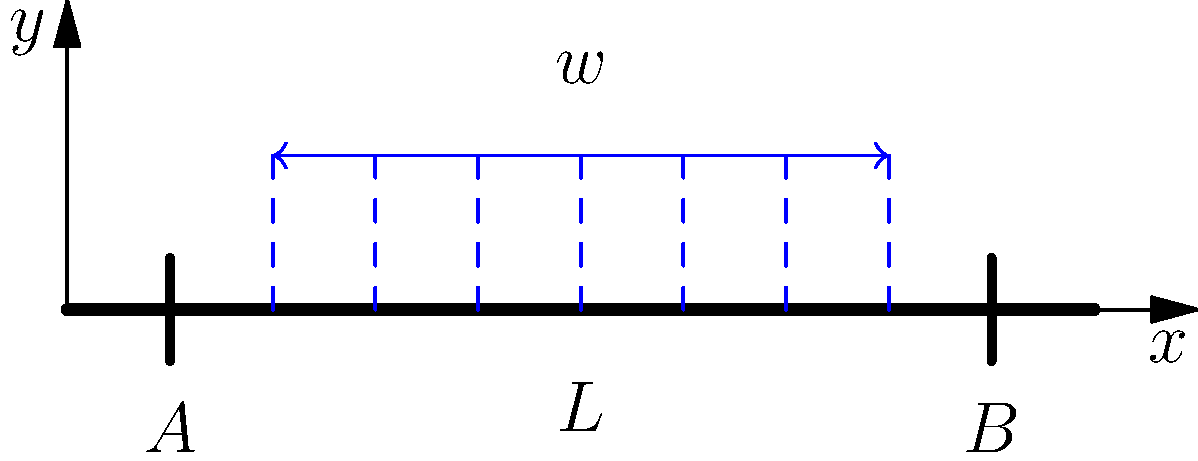Consider a simply supported concrete beam of length $L$ subjected to a uniformly distributed load $w$ as shown in the figure. If the maximum bending moment occurs at the center of the beam, what is the expression for the maximum bending moment $M_{max}$ in terms of $w$ and $L$? To find the maximum bending moment, we'll follow these steps:

1) For a simply supported beam with a uniformly distributed load, the maximum bending moment occurs at the center of the beam.

2) The reaction forces at the supports A and B are equal due to symmetry:
   $R_A = R_B = \frac{wL}{2}$

3) The bending moment at any point $x$ along the beam is given by:
   $M(x) = R_A \cdot x - w \cdot x \cdot \frac{x}{2}$

4) The maximum bending moment occurs at $x = \frac{L}{2}$. Substituting this:
   $M_{max} = M(\frac{L}{2}) = \frac{wL}{2} \cdot \frac{L}{2} - w \cdot \frac{L}{2} \cdot \frac{L}{4}$

5) Simplifying:
   $M_{max} = \frac{wL^2}{8} - \frac{wL^2}{16} = \frac{wL^2}{16}$

6) Therefore, the maximum bending moment is:
   $M_{max} = \frac{wL^2}{8}$

This formula is crucial for designing concrete beams to withstand the maximum stress, ensuring the structural integrity of buildings and infrastructure projects that are vital for Malaysia's development.
Answer: $M_{max} = \frac{wL^2}{8}$ 